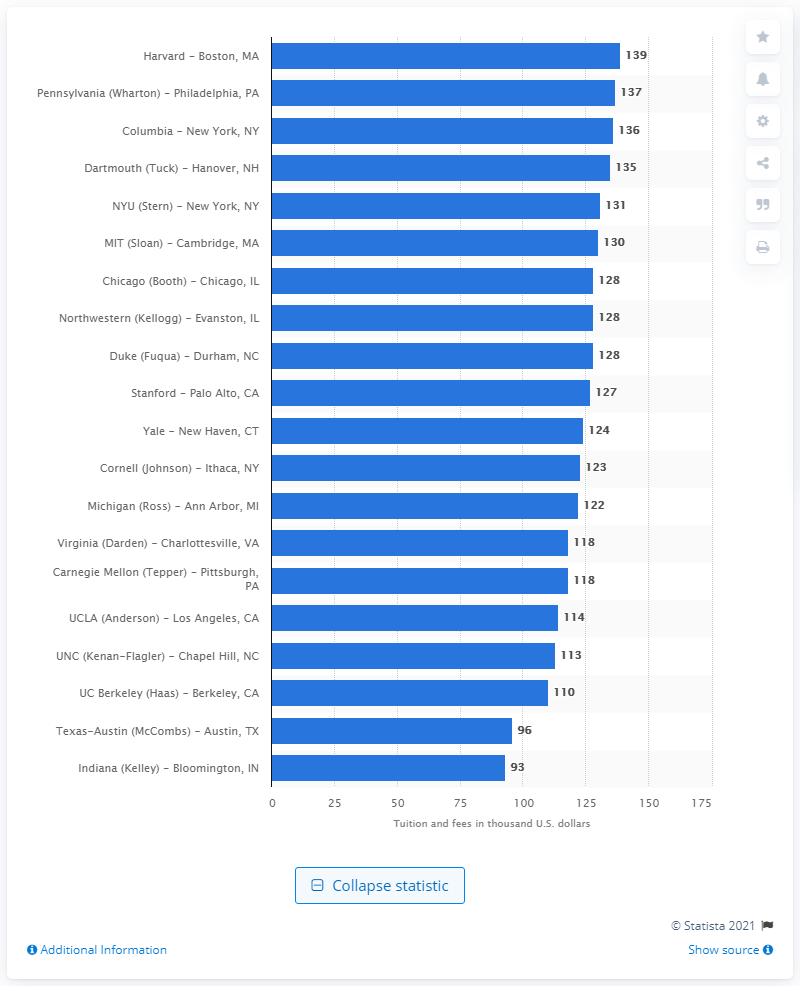Point out several critical features in this image. In 2015, the cost of attending Harvard University was approximately 139... 